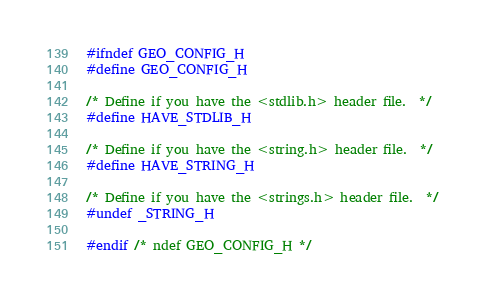<code> <loc_0><loc_0><loc_500><loc_500><_C_>#ifndef GEO_CONFIG_H
#define GEO_CONFIG_H

/* Define if you have the <stdlib.h> header file.  */
#define HAVE_STDLIB_H

/* Define if you have the <string.h> header file.  */
#define HAVE_STRING_H

/* Define if you have the <strings.h> header file.  */
#undef _STRING_H

#endif /* ndef GEO_CONFIG_H */
</code> 